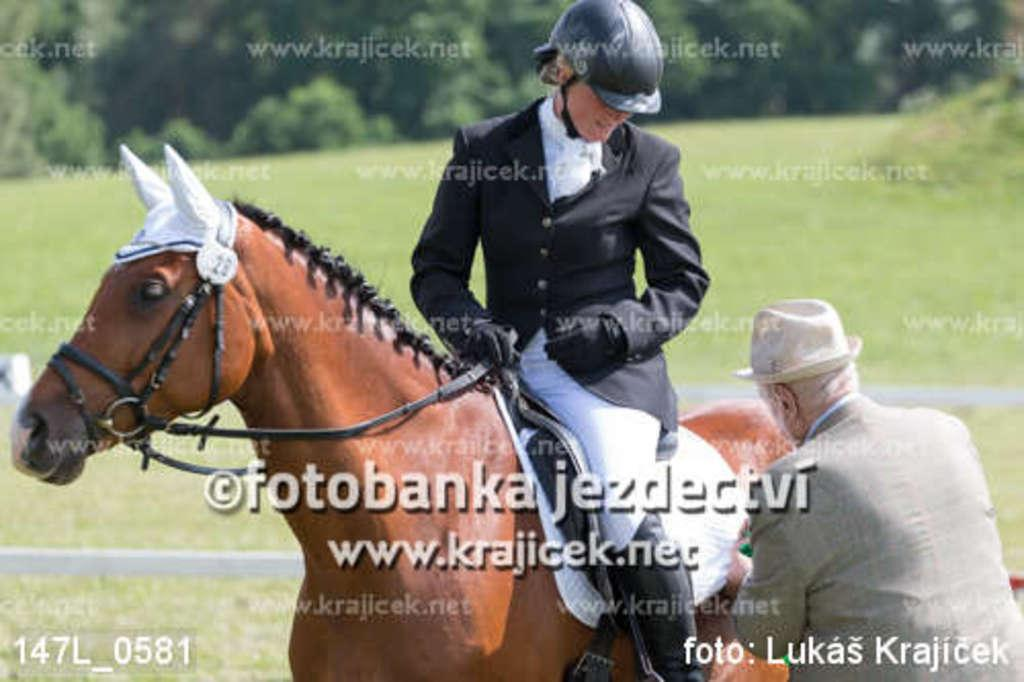What can be found in the image that contains written information? There is some text in the image. How many people are present in the image? There are two people in the image. What protective gear is the man wearing? The man is wearing a helmet and gloves. What is the man doing in the image? The man is sitting on a horse. What type of vegetation is visible in the background of the image? There is grass in the background of the image. What other natural elements can be seen in the background of the image? There are trees in the background of the image. What type of bomb is being diffused by the man in the image? There is no bomb present in the image; the man is sitting on a horse. How does the wind affect the grass in the image? The image does not show any wind, and therefore its effect on the grass cannot be determined. 